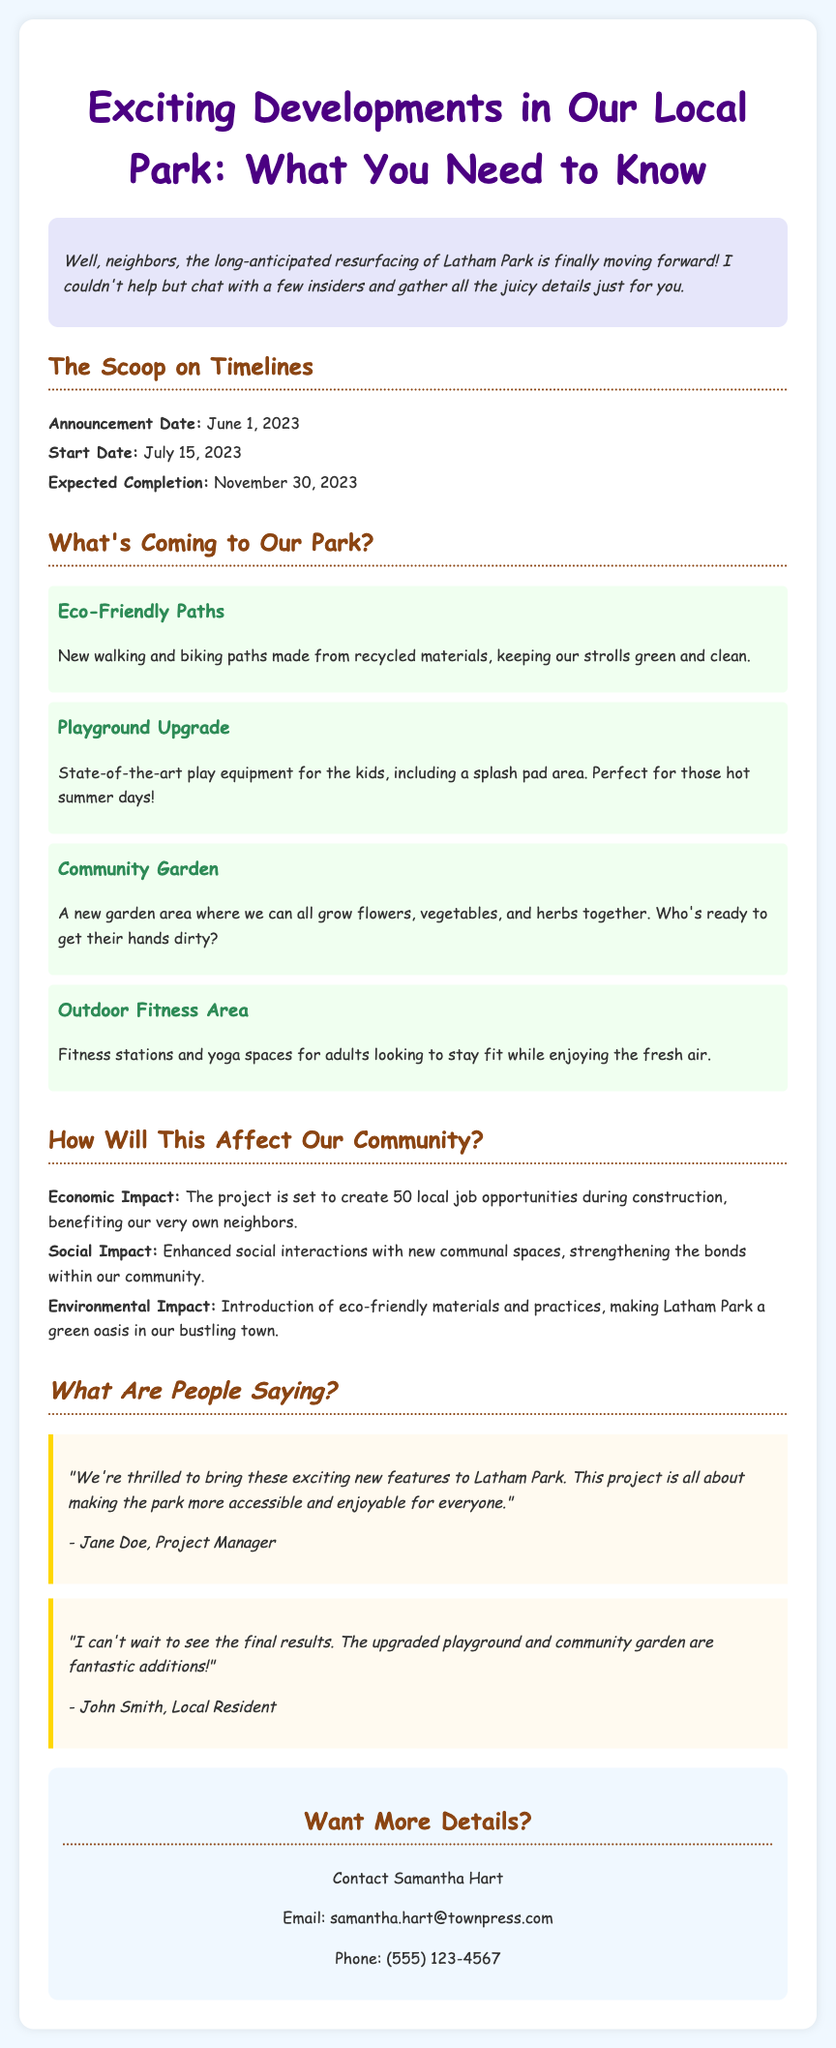What is the expected completion date of the project? The expected completion date is mentioned in the timeline section of the document.
Answer: November 30, 2023 What new feature will be introduced for children? The document states that there will be an upgraded playground.
Answer: Playground Upgrade How many local job opportunities will the project create? The economic impact section provides information about job creation during construction.
Answer: 50 What materials will be used for the new paths? The document specifies that the paths will be made from recycled materials.
Answer: Recycled materials Who is the Project Manager quoted in the release? The quotes section reveals the name of the Project Manager.
Answer: Jane Doe What type of area is planned for fitness? The features section describes an outdoor area dedicated to fitness activities.
Answer: Outdoor Fitness Area What significant social benefit does the project aim to provide? The social impact section talks about enhancing social interactions within the community.
Answer: Enhanced social interactions When was the project announced? The announcement date is clearly listed in the document's timeline section.
Answer: June 1, 2023 Who can be contacted for more details? The contact section contains the name of the person to reach out to.
Answer: Samantha Hart 